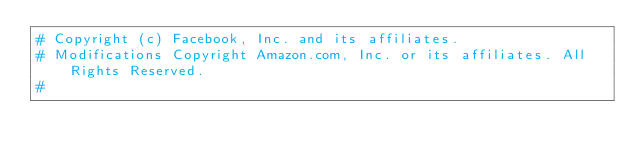<code> <loc_0><loc_0><loc_500><loc_500><_Python_># Copyright (c) Facebook, Inc. and its affiliates.
# Modifications Copyright Amazon.com, Inc. or its affiliates. All Rights Reserved.
#</code> 